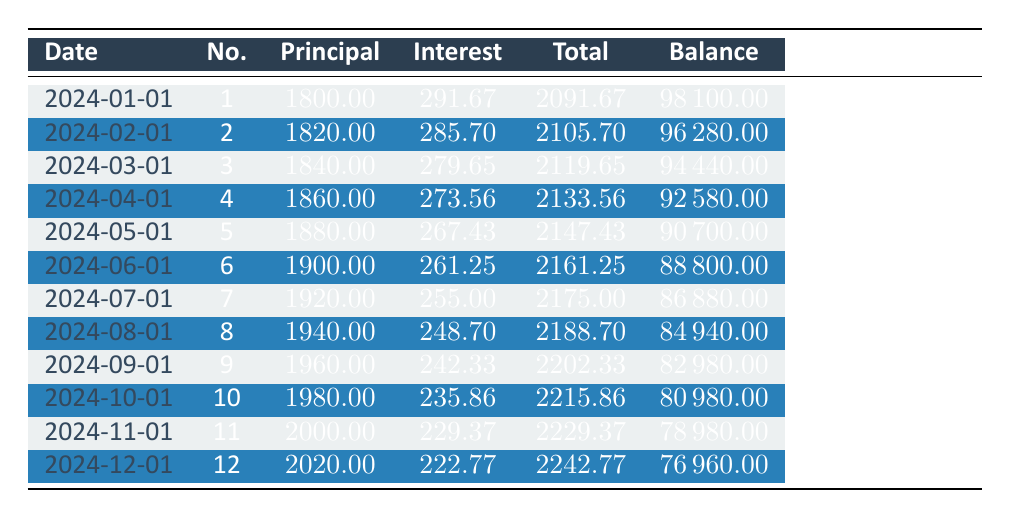What is the total principal payment made in the first three payments? Adding the principal payments for the first three payments gives us 1800 + 1820 + 1840 = 5460.
Answer: 5460 What is the total payment in the seventh month? The total payment for the seventh month is directly provided in the table as 2175.00.
Answer: 2175.00 Is the interest payment in the first month greater than the interest payment in the last month? The interest payment in the first month is 291.67, and in the last month, it is 222.77. Since 291.67 is greater than 222.77, the statement is true.
Answer: Yes What is the remaining balance after the fifth payment? Looking at the fifth payment in the table, the remaining balance is 90700.00.
Answer: 90700.00 What is the average total payment over the first 12 months? The average total payment can be calculated by summing the total payments for all 12 months: (2091.67 + 2105.70 + 2119.65 + 2133.56 + 2147.43 + 2161.25 + 2175.00 + 2188.70 + 2202.33 + 2215.86 + 2229.37 + 2242.77) equals 25655.27. Dividing this by 12 results in an average of 2137.94.
Answer: 2137.94 What is the increase in the principal payment from the first to the eighth month? Comparing the principal payment of the first month (1800) to the eighth month (1940), we find the increase is 1940 - 1800 = 140.
Answer: 140 